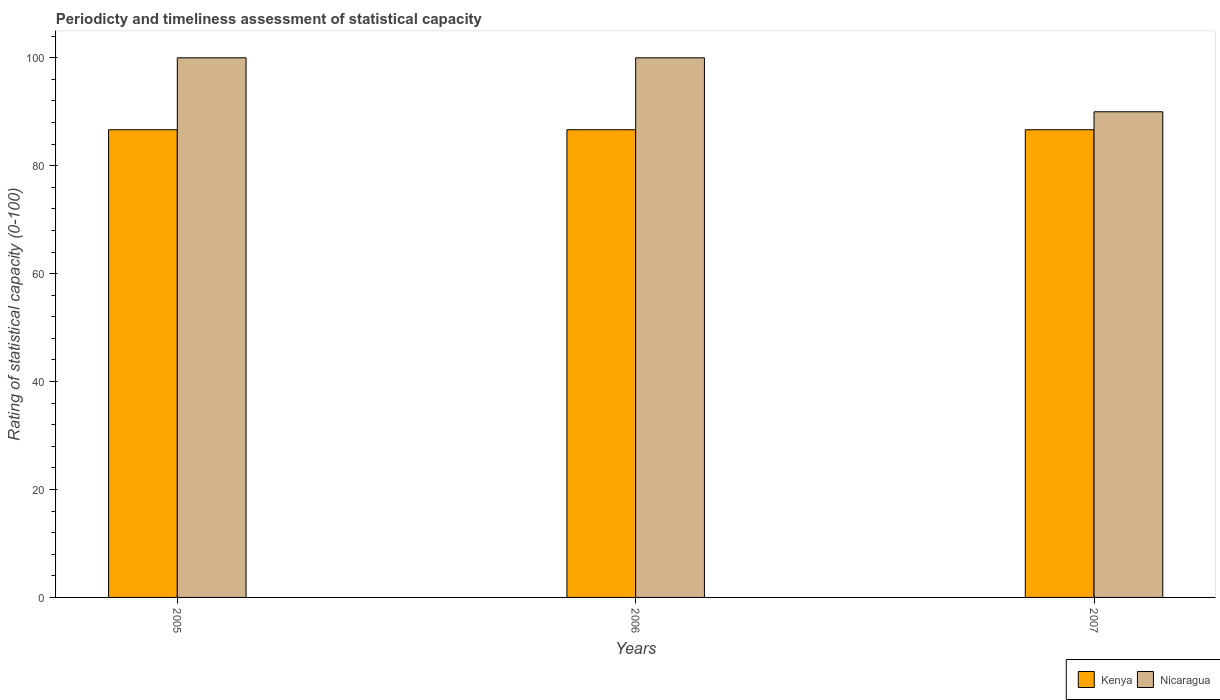How many different coloured bars are there?
Give a very brief answer. 2. Are the number of bars per tick equal to the number of legend labels?
Offer a very short reply. Yes. Across all years, what is the maximum rating of statistical capacity in Kenya?
Your answer should be compact. 86.67. Across all years, what is the minimum rating of statistical capacity in Kenya?
Offer a terse response. 86.67. In which year was the rating of statistical capacity in Nicaragua maximum?
Provide a succinct answer. 2005. What is the total rating of statistical capacity in Kenya in the graph?
Keep it short and to the point. 260. What is the difference between the rating of statistical capacity in Kenya in 2005 and the rating of statistical capacity in Nicaragua in 2006?
Make the answer very short. -13.33. What is the average rating of statistical capacity in Kenya per year?
Make the answer very short. 86.67. In the year 2007, what is the difference between the rating of statistical capacity in Kenya and rating of statistical capacity in Nicaragua?
Ensure brevity in your answer.  -3.33. What is the ratio of the rating of statistical capacity in Nicaragua in 2006 to that in 2007?
Keep it short and to the point. 1.11. Is the rating of statistical capacity in Kenya in 2005 less than that in 2006?
Ensure brevity in your answer.  No. What is the difference between the highest and the second highest rating of statistical capacity in Nicaragua?
Your answer should be very brief. 0. What is the difference between the highest and the lowest rating of statistical capacity in Nicaragua?
Offer a terse response. 10. What does the 2nd bar from the left in 2006 represents?
Offer a very short reply. Nicaragua. What does the 2nd bar from the right in 2007 represents?
Provide a short and direct response. Kenya. How many bars are there?
Offer a very short reply. 6. Are all the bars in the graph horizontal?
Your response must be concise. No. What is the difference between two consecutive major ticks on the Y-axis?
Provide a short and direct response. 20. Are the values on the major ticks of Y-axis written in scientific E-notation?
Offer a very short reply. No. Does the graph contain grids?
Offer a very short reply. No. Where does the legend appear in the graph?
Your answer should be very brief. Bottom right. How many legend labels are there?
Give a very brief answer. 2. What is the title of the graph?
Offer a terse response. Periodicty and timeliness assessment of statistical capacity. Does "India" appear as one of the legend labels in the graph?
Offer a very short reply. No. What is the label or title of the X-axis?
Your answer should be compact. Years. What is the label or title of the Y-axis?
Give a very brief answer. Rating of statistical capacity (0-100). What is the Rating of statistical capacity (0-100) of Kenya in 2005?
Make the answer very short. 86.67. What is the Rating of statistical capacity (0-100) of Nicaragua in 2005?
Ensure brevity in your answer.  100. What is the Rating of statistical capacity (0-100) of Kenya in 2006?
Offer a very short reply. 86.67. What is the Rating of statistical capacity (0-100) in Kenya in 2007?
Make the answer very short. 86.67. What is the Rating of statistical capacity (0-100) of Nicaragua in 2007?
Offer a very short reply. 90. Across all years, what is the maximum Rating of statistical capacity (0-100) of Kenya?
Provide a succinct answer. 86.67. Across all years, what is the minimum Rating of statistical capacity (0-100) in Kenya?
Your answer should be very brief. 86.67. Across all years, what is the minimum Rating of statistical capacity (0-100) of Nicaragua?
Ensure brevity in your answer.  90. What is the total Rating of statistical capacity (0-100) in Kenya in the graph?
Provide a short and direct response. 260. What is the total Rating of statistical capacity (0-100) in Nicaragua in the graph?
Give a very brief answer. 290. What is the difference between the Rating of statistical capacity (0-100) in Nicaragua in 2005 and that in 2007?
Ensure brevity in your answer.  10. What is the difference between the Rating of statistical capacity (0-100) in Kenya in 2005 and the Rating of statistical capacity (0-100) in Nicaragua in 2006?
Offer a very short reply. -13.33. What is the difference between the Rating of statistical capacity (0-100) in Kenya in 2005 and the Rating of statistical capacity (0-100) in Nicaragua in 2007?
Your response must be concise. -3.33. What is the average Rating of statistical capacity (0-100) in Kenya per year?
Ensure brevity in your answer.  86.67. What is the average Rating of statistical capacity (0-100) in Nicaragua per year?
Offer a very short reply. 96.67. In the year 2005, what is the difference between the Rating of statistical capacity (0-100) in Kenya and Rating of statistical capacity (0-100) in Nicaragua?
Provide a succinct answer. -13.33. In the year 2006, what is the difference between the Rating of statistical capacity (0-100) of Kenya and Rating of statistical capacity (0-100) of Nicaragua?
Give a very brief answer. -13.33. In the year 2007, what is the difference between the Rating of statistical capacity (0-100) of Kenya and Rating of statistical capacity (0-100) of Nicaragua?
Your answer should be compact. -3.33. What is the ratio of the Rating of statistical capacity (0-100) of Kenya in 2005 to that in 2007?
Make the answer very short. 1. What is the ratio of the Rating of statistical capacity (0-100) of Nicaragua in 2005 to that in 2007?
Your response must be concise. 1.11. What is the ratio of the Rating of statistical capacity (0-100) in Kenya in 2006 to that in 2007?
Provide a short and direct response. 1. What is the difference between the highest and the second highest Rating of statistical capacity (0-100) in Nicaragua?
Your response must be concise. 0. 